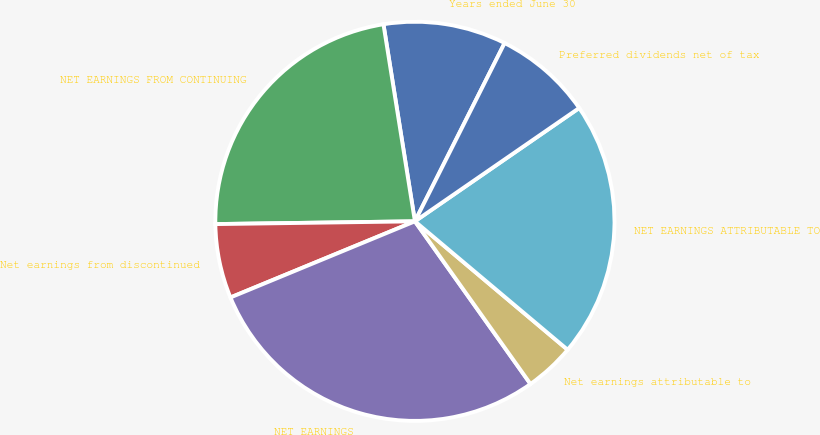Convert chart to OTSL. <chart><loc_0><loc_0><loc_500><loc_500><pie_chart><fcel>Years ended June 30<fcel>NET EARNINGS FROM CONTINUING<fcel>Net earnings from discontinued<fcel>NET EARNINGS<fcel>Net earnings attributable to<fcel>NET EARNINGS ATTRIBUTABLE TO<fcel>Preferred dividends net of tax<nl><fcel>9.94%<fcel>22.7%<fcel>6.01%<fcel>28.6%<fcel>4.04%<fcel>20.74%<fcel>7.97%<nl></chart> 